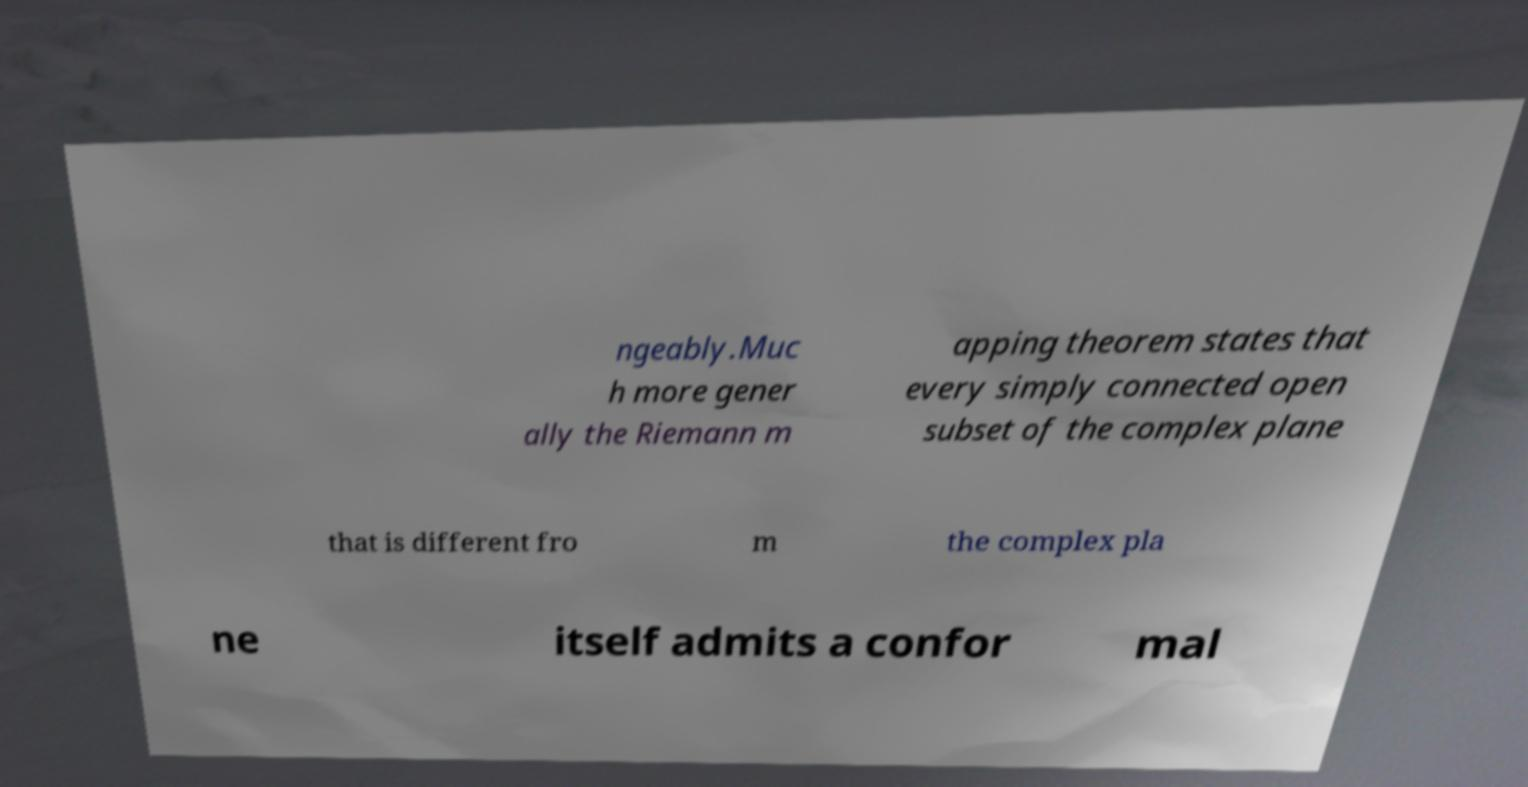There's text embedded in this image that I need extracted. Can you transcribe it verbatim? ngeably.Muc h more gener ally the Riemann m apping theorem states that every simply connected open subset of the complex plane that is different fro m the complex pla ne itself admits a confor mal 